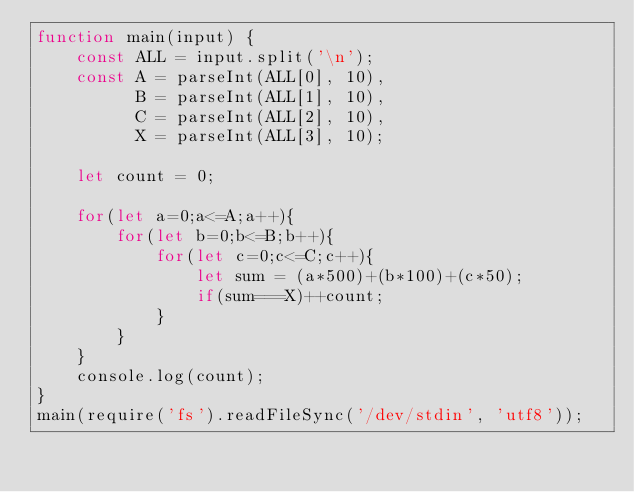Convert code to text. <code><loc_0><loc_0><loc_500><loc_500><_JavaScript_>function main(input) {
    const ALL = input.split('\n');
    const A = parseInt(ALL[0], 10),
          B = parseInt(ALL[1], 10),
          C = parseInt(ALL[2], 10),
          X = parseInt(ALL[3], 10);

    let count = 0;

    for(let a=0;a<=A;a++){
        for(let b=0;b<=B;b++){
            for(let c=0;c<=C;c++){
                let sum = (a*500)+(b*100)+(c*50);
                if(sum===X)++count;
            }
        }
    }
    console.log(count);
}
main(require('fs').readFileSync('/dev/stdin', 'utf8'));</code> 